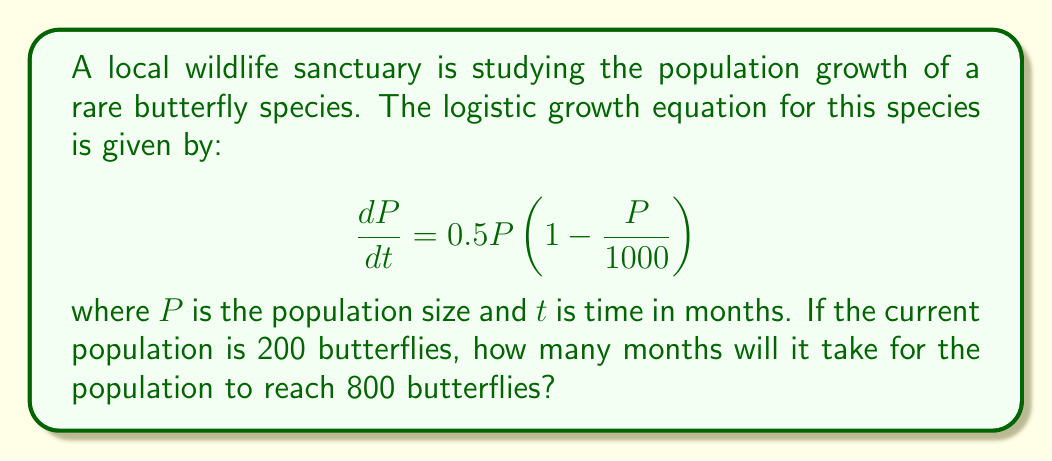Could you help me with this problem? To solve this problem, we need to use the integrated form of the logistic equation:

$$P(t) = \frac{K}{1 + \left(\frac{K}{P_0} - 1\right)e^{-rt}}$$

Where:
- $K$ is the carrying capacity (1000 in this case)
- $P_0$ is the initial population (200)
- $r$ is the growth rate (0.5 in this case)
- $t$ is the time we're solving for

Let's substitute the known values:

$$800 = \frac{1000}{1 + \left(\frac{1000}{200} - 1\right)e^{-0.5t}}$$

Now, let's solve for $t$:

1) Simplify the fraction:
   $$800 = \frac{1000}{1 + 4e^{-0.5t}}$$

2) Multiply both sides by $(1 + 4e^{-0.5t})$:
   $$800(1 + 4e^{-0.5t}) = 1000$$

3) Expand:
   $$800 + 3200e^{-0.5t} = 1000$$

4) Subtract 800 from both sides:
   $$3200e^{-0.5t} = 200$$

5) Divide both sides by 3200:
   $$e^{-0.5t} = \frac{1}{16}$$

6) Take the natural log of both sides:
   $$-0.5t = \ln\left(\frac{1}{16}\right) = -\ln(16)$$

7) Divide both sides by -0.5:
   $$t = \frac{\ln(16)}{0.5} \approx 5.55$$

Therefore, it will take approximately 5.55 months for the population to reach 800 butterflies.
Answer: 5.55 months 